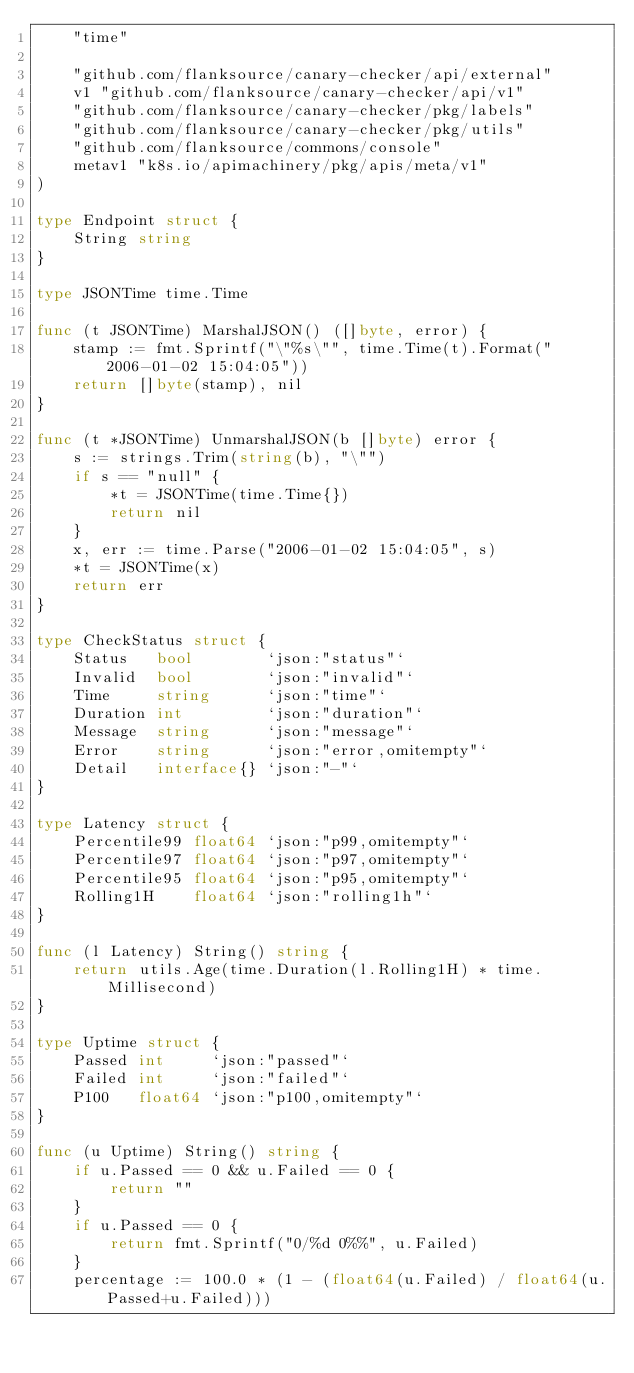Convert code to text. <code><loc_0><loc_0><loc_500><loc_500><_Go_>	"time"

	"github.com/flanksource/canary-checker/api/external"
	v1 "github.com/flanksource/canary-checker/api/v1"
	"github.com/flanksource/canary-checker/pkg/labels"
	"github.com/flanksource/canary-checker/pkg/utils"
	"github.com/flanksource/commons/console"
	metav1 "k8s.io/apimachinery/pkg/apis/meta/v1"
)

type Endpoint struct {
	String string
}

type JSONTime time.Time

func (t JSONTime) MarshalJSON() ([]byte, error) {
	stamp := fmt.Sprintf("\"%s\"", time.Time(t).Format("2006-01-02 15:04:05"))
	return []byte(stamp), nil
}

func (t *JSONTime) UnmarshalJSON(b []byte) error {
	s := strings.Trim(string(b), "\"")
	if s == "null" {
		*t = JSONTime(time.Time{})
		return nil
	}
	x, err := time.Parse("2006-01-02 15:04:05", s)
	*t = JSONTime(x)
	return err
}

type CheckStatus struct {
	Status   bool        `json:"status"`
	Invalid  bool        `json:"invalid"`
	Time     string      `json:"time"`
	Duration int         `json:"duration"`
	Message  string      `json:"message"`
	Error    string      `json:"error,omitempty"`
	Detail   interface{} `json:"-"`
}

type Latency struct {
	Percentile99 float64 `json:"p99,omitempty"`
	Percentile97 float64 `json:"p97,omitempty"`
	Percentile95 float64 `json:"p95,omitempty"`
	Rolling1H    float64 `json:"rolling1h"`
}

func (l Latency) String() string {
	return utils.Age(time.Duration(l.Rolling1H) * time.Millisecond)
}

type Uptime struct {
	Passed int     `json:"passed"`
	Failed int     `json:"failed"`
	P100   float64 `json:"p100,omitempty"`
}

func (u Uptime) String() string {
	if u.Passed == 0 && u.Failed == 0 {
		return ""
	}
	if u.Passed == 0 {
		return fmt.Sprintf("0/%d 0%%", u.Failed)
	}
	percentage := 100.0 * (1 - (float64(u.Failed) / float64(u.Passed+u.Failed)))</code> 